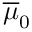Convert formula to latex. <formula><loc_0><loc_0><loc_500><loc_500>\overline { \mu } _ { 0 }</formula> 